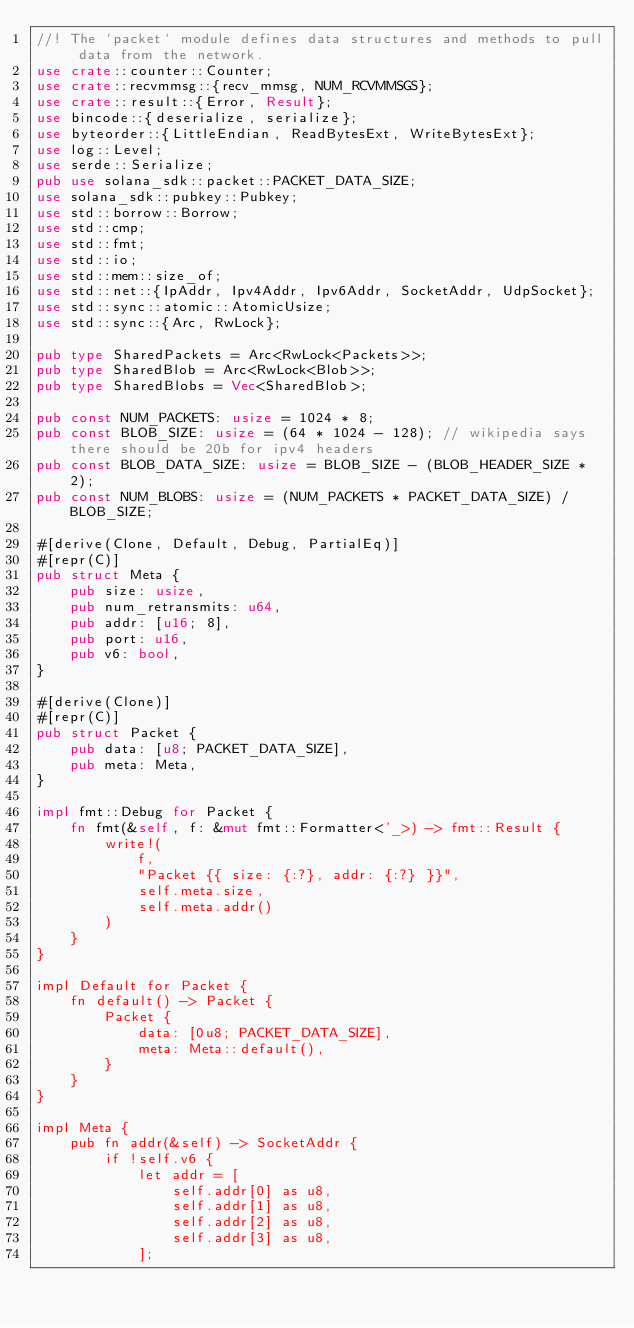Convert code to text. <code><loc_0><loc_0><loc_500><loc_500><_Rust_>//! The `packet` module defines data structures and methods to pull data from the network.
use crate::counter::Counter;
use crate::recvmmsg::{recv_mmsg, NUM_RCVMMSGS};
use crate::result::{Error, Result};
use bincode::{deserialize, serialize};
use byteorder::{LittleEndian, ReadBytesExt, WriteBytesExt};
use log::Level;
use serde::Serialize;
pub use solana_sdk::packet::PACKET_DATA_SIZE;
use solana_sdk::pubkey::Pubkey;
use std::borrow::Borrow;
use std::cmp;
use std::fmt;
use std::io;
use std::mem::size_of;
use std::net::{IpAddr, Ipv4Addr, Ipv6Addr, SocketAddr, UdpSocket};
use std::sync::atomic::AtomicUsize;
use std::sync::{Arc, RwLock};

pub type SharedPackets = Arc<RwLock<Packets>>;
pub type SharedBlob = Arc<RwLock<Blob>>;
pub type SharedBlobs = Vec<SharedBlob>;

pub const NUM_PACKETS: usize = 1024 * 8;
pub const BLOB_SIZE: usize = (64 * 1024 - 128); // wikipedia says there should be 20b for ipv4 headers
pub const BLOB_DATA_SIZE: usize = BLOB_SIZE - (BLOB_HEADER_SIZE * 2);
pub const NUM_BLOBS: usize = (NUM_PACKETS * PACKET_DATA_SIZE) / BLOB_SIZE;

#[derive(Clone, Default, Debug, PartialEq)]
#[repr(C)]
pub struct Meta {
    pub size: usize,
    pub num_retransmits: u64,
    pub addr: [u16; 8],
    pub port: u16,
    pub v6: bool,
}

#[derive(Clone)]
#[repr(C)]
pub struct Packet {
    pub data: [u8; PACKET_DATA_SIZE],
    pub meta: Meta,
}

impl fmt::Debug for Packet {
    fn fmt(&self, f: &mut fmt::Formatter<'_>) -> fmt::Result {
        write!(
            f,
            "Packet {{ size: {:?}, addr: {:?} }}",
            self.meta.size,
            self.meta.addr()
        )
    }
}

impl Default for Packet {
    fn default() -> Packet {
        Packet {
            data: [0u8; PACKET_DATA_SIZE],
            meta: Meta::default(),
        }
    }
}

impl Meta {
    pub fn addr(&self) -> SocketAddr {
        if !self.v6 {
            let addr = [
                self.addr[0] as u8,
                self.addr[1] as u8,
                self.addr[2] as u8,
                self.addr[3] as u8,
            ];</code> 